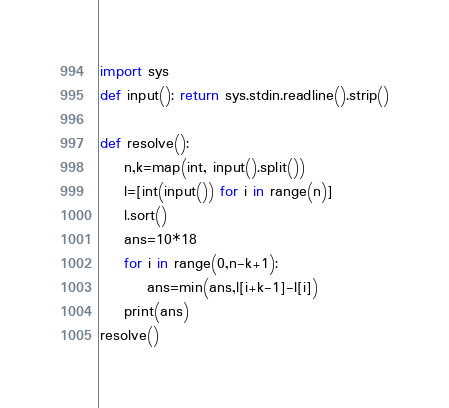Convert code to text. <code><loc_0><loc_0><loc_500><loc_500><_Python_>import sys
def input(): return sys.stdin.readline().strip()

def resolve():
    n,k=map(int, input().split())
    l=[int(input()) for i in range(n)]
    l.sort()
    ans=10*18
    for i in range(0,n-k+1):
        ans=min(ans,l[i+k-1]-l[i])
    print(ans)
resolve()</code> 